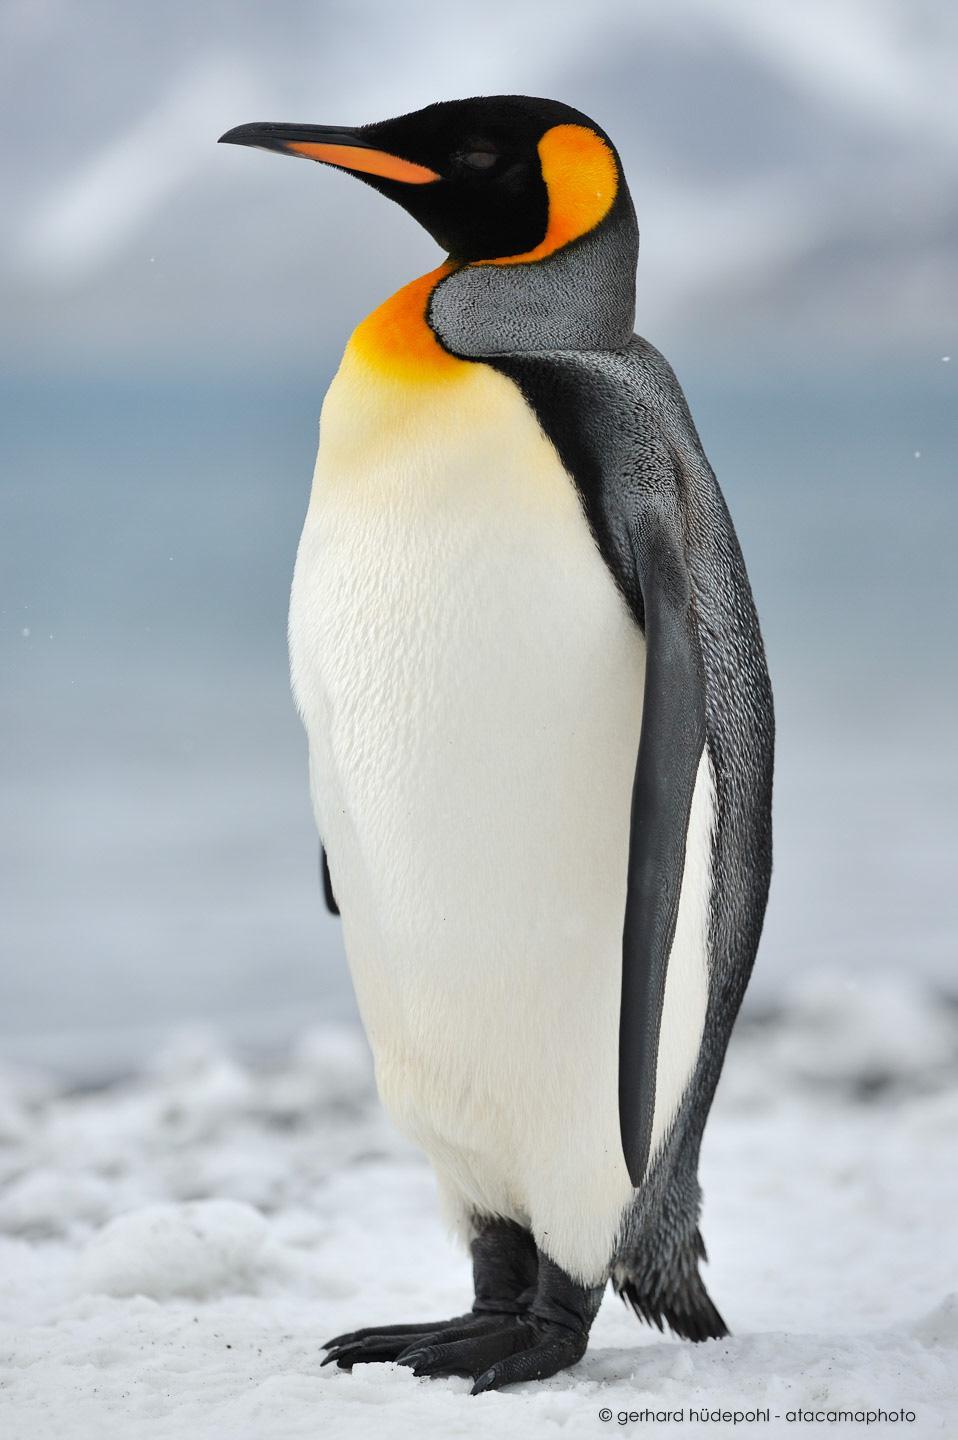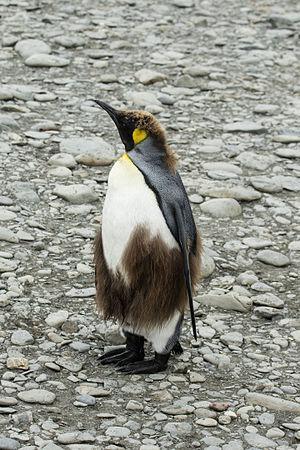The first image is the image on the left, the second image is the image on the right. Examine the images to the left and right. Is the description "There are exactly two penguins." accurate? Answer yes or no. Yes. 